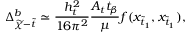Convert formula to latex. <formula><loc_0><loc_0><loc_500><loc_500>\Delta _ { \widetilde { \chi } - \widetilde { t } } ^ { b } \simeq \frac { h _ { t } ^ { 2 } } { 1 6 \pi ^ { 2 } } \frac { A _ { t } t _ { \beta } } { \mu } f ( x _ { \widetilde { t } _ { 1 } } , x _ { \widetilde { t } _ { 1 } } ) ,</formula> 